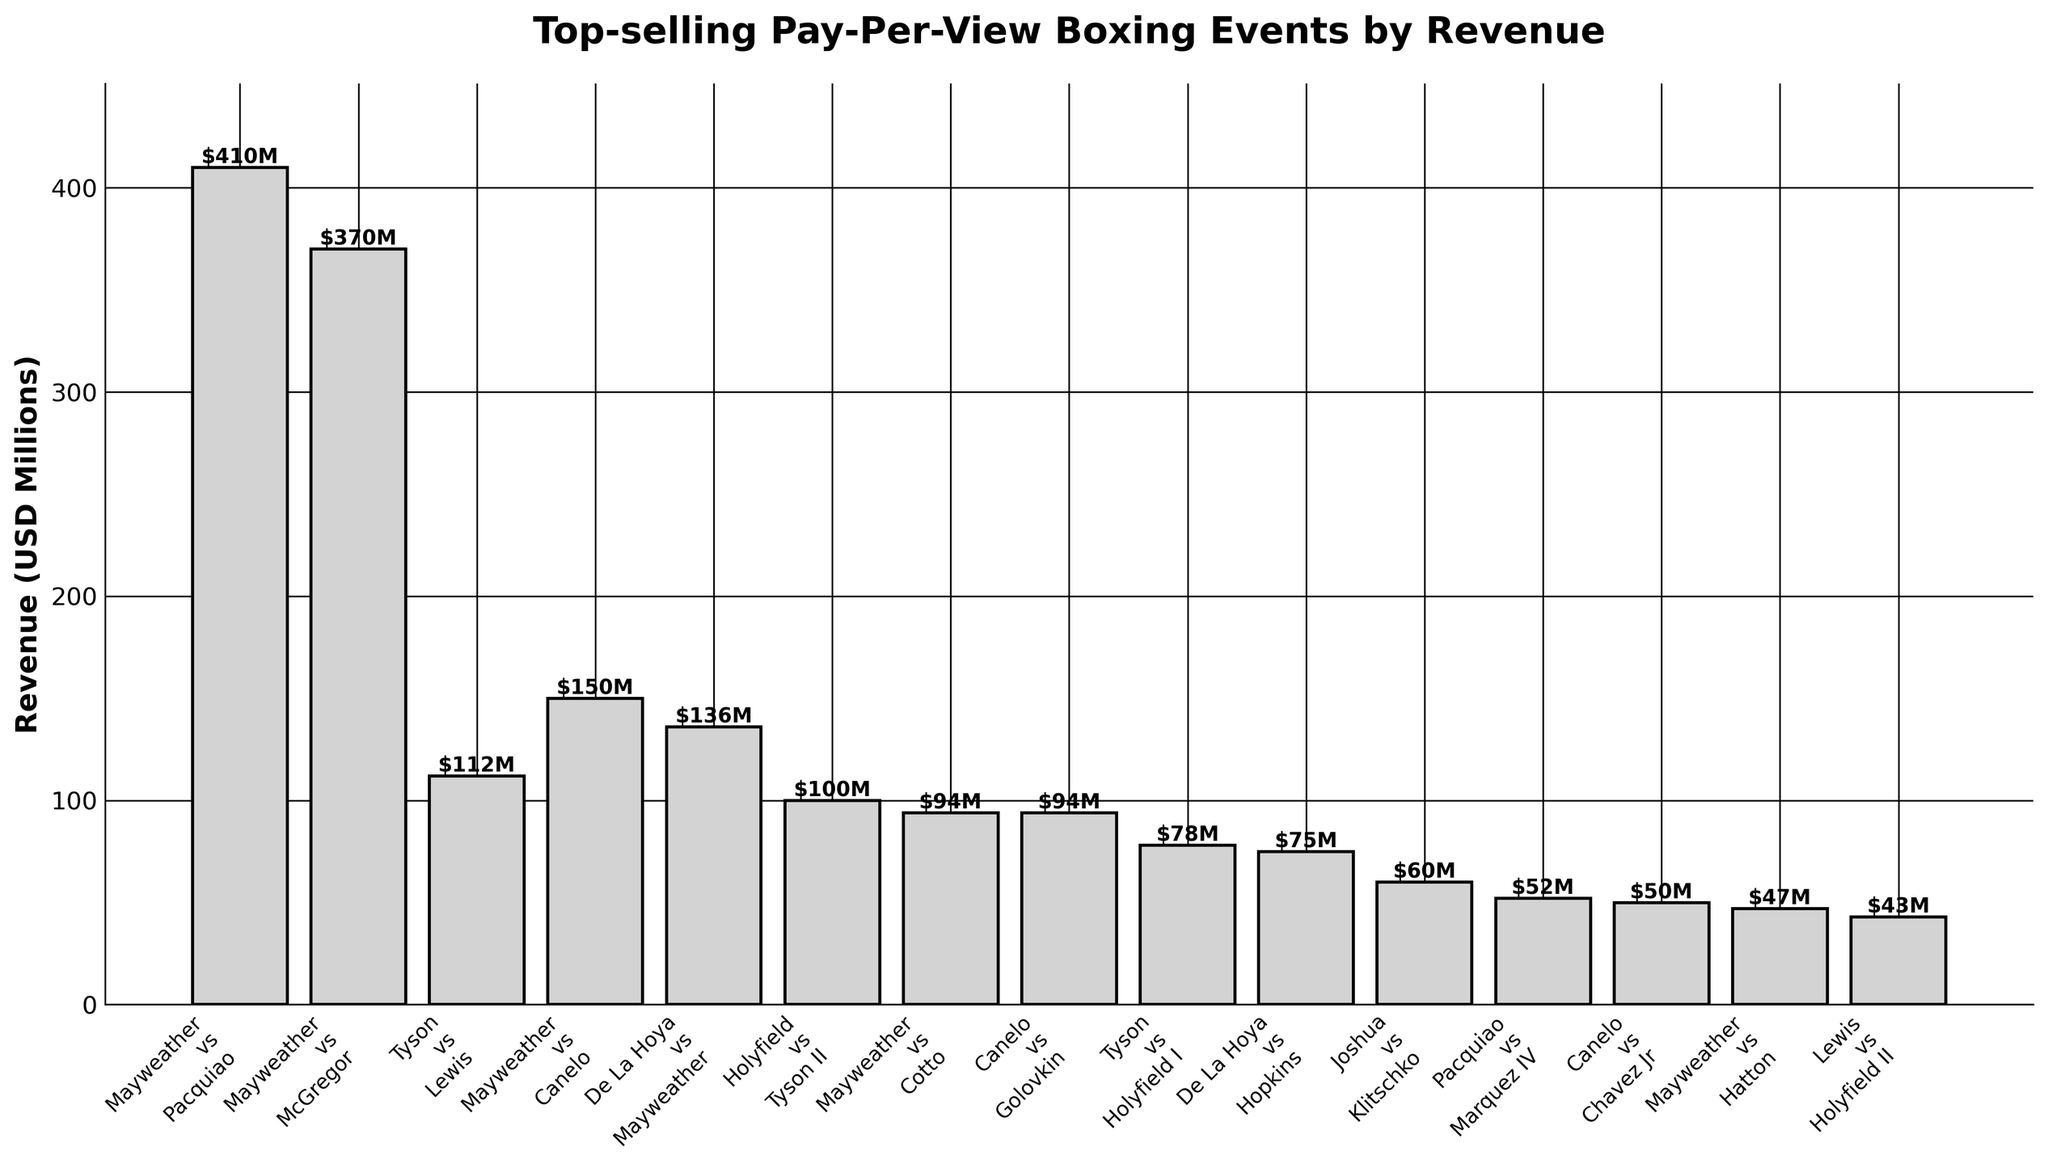What's the total revenue of all the Mayweather events combined? There are five Mayweather events in the list. Summing their revenues: Mayweather vs Pacquiao ($410M) + Mayweather vs McGregor ($370M) + Mayweather vs Canelo ($150M) + De La Hoya vs Mayweather ($136M) + Mayweather vs Cotto ($94M) = $1160M
Answer: $1160M Which event generated the highest revenue, and how much was it? Looking at the bar chart, the event with the highest bar is Mayweather vs Pacquiao with a revenue of $410M
Answer: Mayweather vs Pacquiao, $410M How does the revenue of Mayweather vs McGregor compare to Tyson vs Lewis? Comparing the heights of the bars, Mayweather vs McGregor generated $370M whereas Tyson vs Lewis generated $112M. Therefore, Mayweather vs McGregor generated more revenue by $258M.
Answer: Mayweather vs McGregor, $258M more Which event generated the lowest revenue, and what was the amount? The shortest bar represents the event with the lowest revenue, which is Lewis vs Holyfield II with a revenue of $43M
Answer: Lewis vs Holyfield II, $43M Is the combined revenue of all Tyson events higher or lower than the revenue of Mayweather vs Pacquiao? Summing the revenues of all Tyson events: Tyson vs Lewis ($112M) + Holyfield vs Tyson II ($100M) + Tyson vs Holyfield I ($78M) = $290M. Comparing it with Mayweather vs Pacquiao ($410M), the combined revenue of Tyson events is lower by $120M
Answer: Lower, $290M What is the average revenue of the listed events? To find the average, sum all the revenues and divide by the number of events. Total revenue is $1921M and there are 15 events, so the average is $1921M / 15 ≈ $128.07M
Answer: $128.07M Among the listed events, how many generated more than $100 million in revenue? Identifying the bars representing revenues over $100M: Mayweather vs Pacquiao ($410M), Mayweather vs McGregor ($370M), Tyson vs Lewis ($112M), Mayweather vs Canelo ($150M), De La Hoya vs Mayweather ($136M), Holyfield vs Tyson II ($100M). There are 6 such events.
Answer: 6 Which events have the same revenue, and what is that amount? Observing the bars, Mayweather vs Cotto and Canelo vs Golovkin have bars of the same height, both generating $94M
Answer: Mayweather vs Cotto and Canelo vs Golovkin, $94M How does the revenue of the second highest event compare to the third highest event? The second highest event is Mayweather vs McGregor ($370M) and the third highest is Mayweather vs Canelo ($150M). The difference is $370M - $150M = $220M
Answer: $220M What’s the difference in revenue between De La Hoya vs Hopkins and Pacquiao vs Marquez IV? De La Hoya vs Hopkins generated $75M and Pacquiao vs Marquez IV generated $52M. The difference is $75M - $52M = $23M
Answer: $23M 